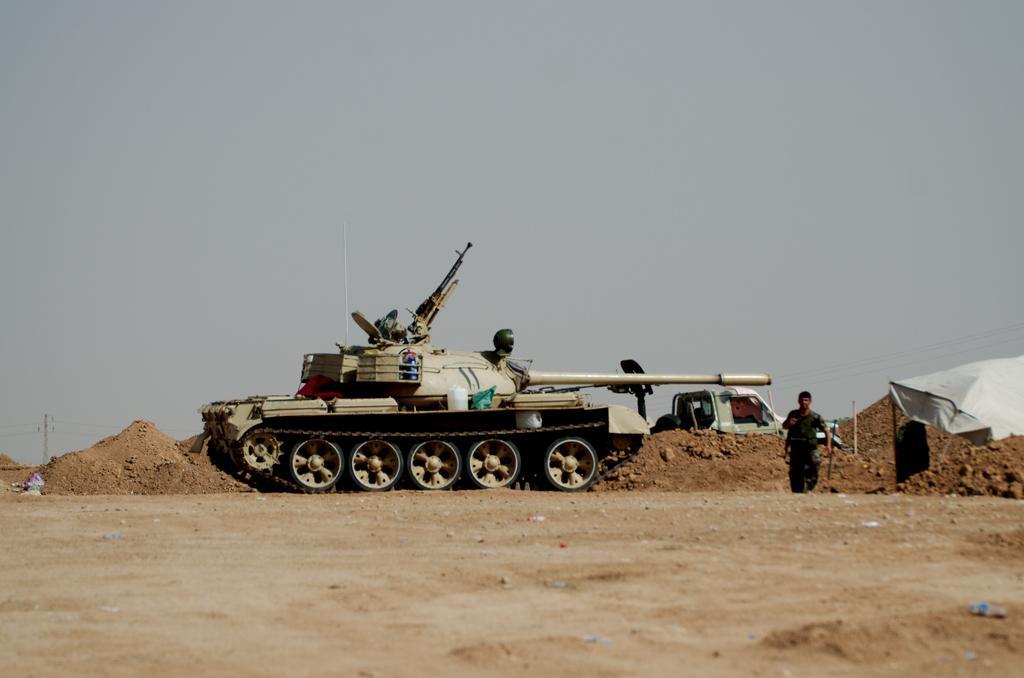Could you give a brief overview of what you see in this image? In this image we can see a battle tank on the ground, a person on the tank, a person on standing on the ground, a white color object looks like cloth and in the background there is sand, a current pole with wires, a vehicle and the sky. 